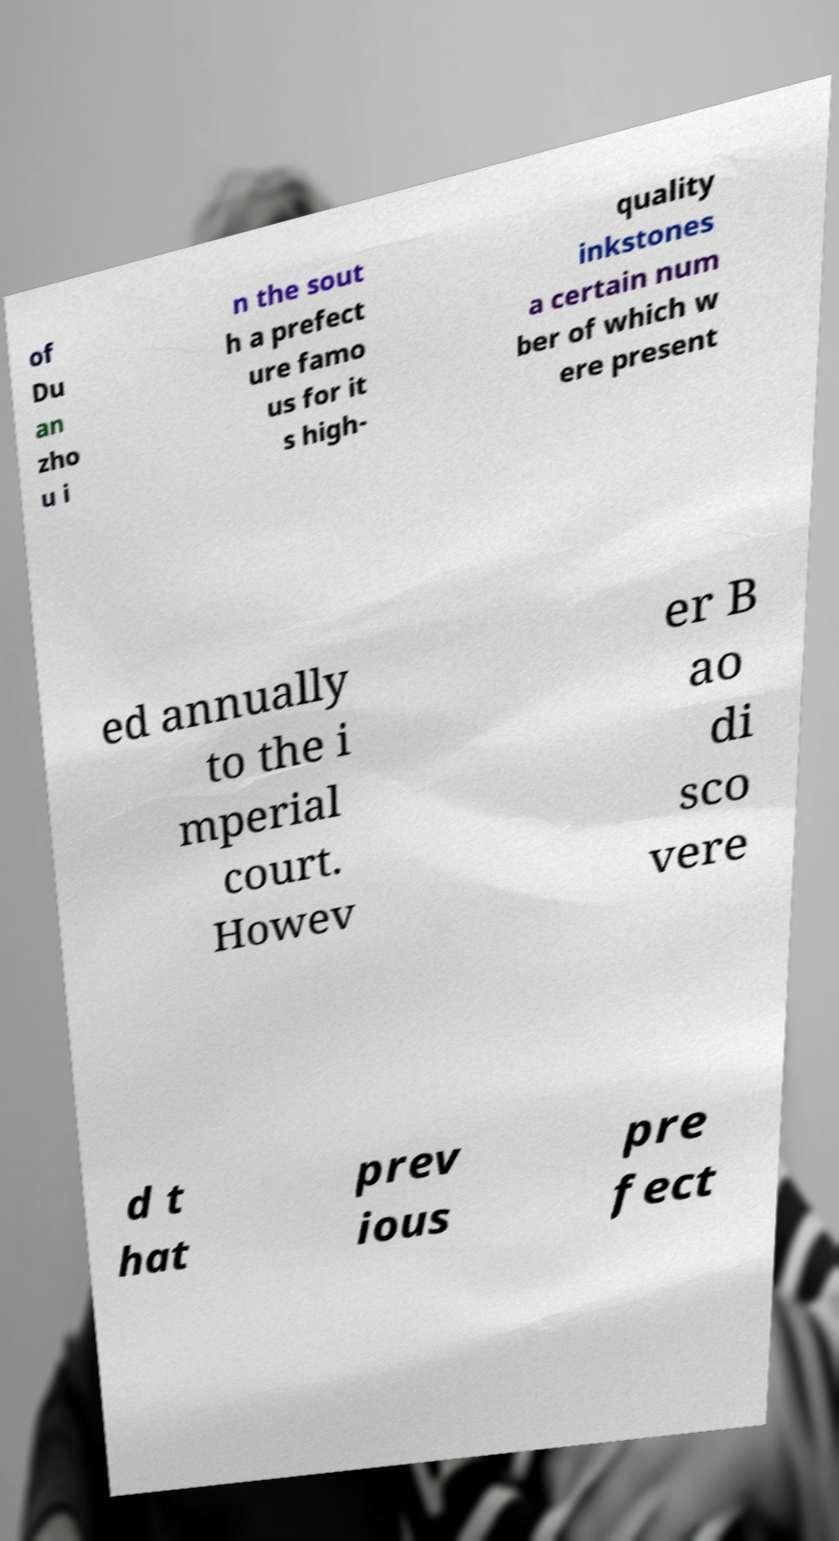There's text embedded in this image that I need extracted. Can you transcribe it verbatim? of Du an zho u i n the sout h a prefect ure famo us for it s high- quality inkstones a certain num ber of which w ere present ed annually to the i mperial court. Howev er B ao di sco vere d t hat prev ious pre fect 